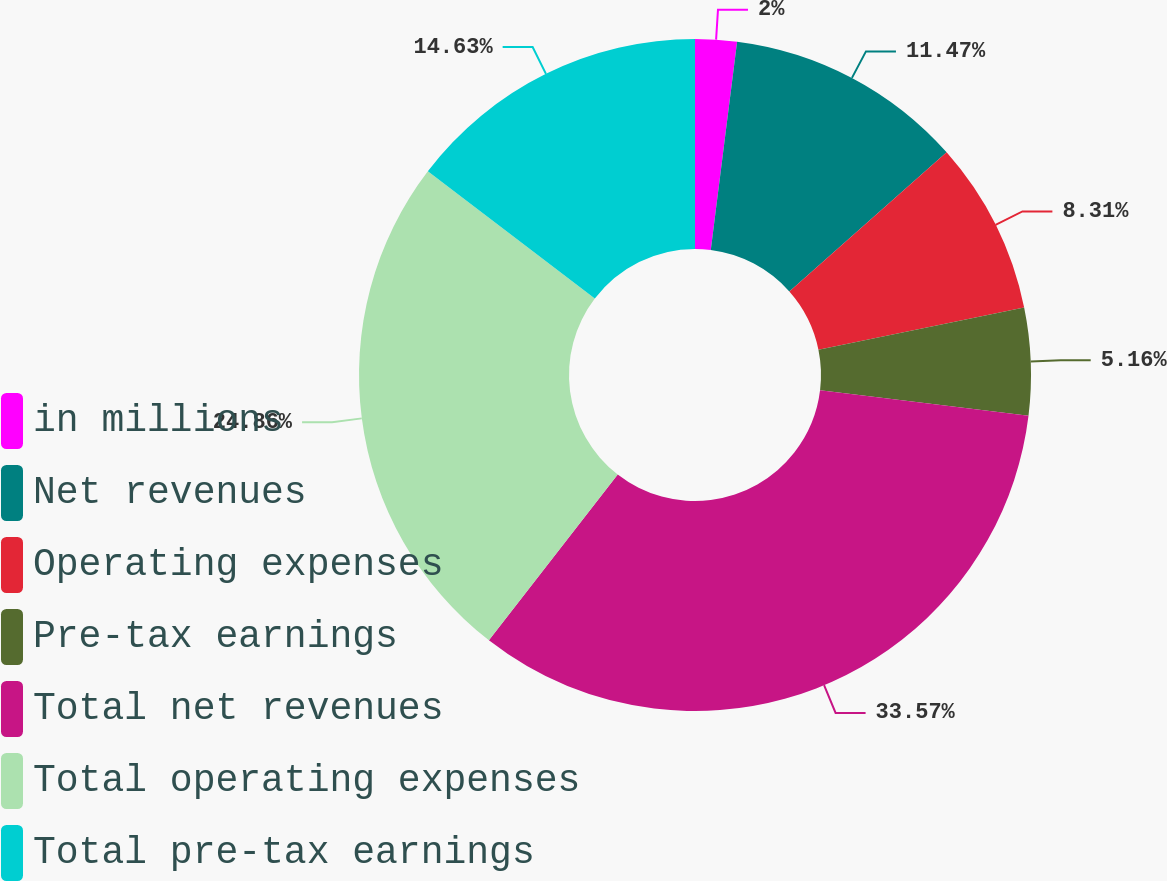Convert chart. <chart><loc_0><loc_0><loc_500><loc_500><pie_chart><fcel>in millions<fcel>Net revenues<fcel>Operating expenses<fcel>Pre-tax earnings<fcel>Total net revenues<fcel>Total operating expenses<fcel>Total pre-tax earnings<nl><fcel>2.0%<fcel>11.47%<fcel>8.31%<fcel>5.16%<fcel>33.57%<fcel>24.86%<fcel>14.63%<nl></chart> 